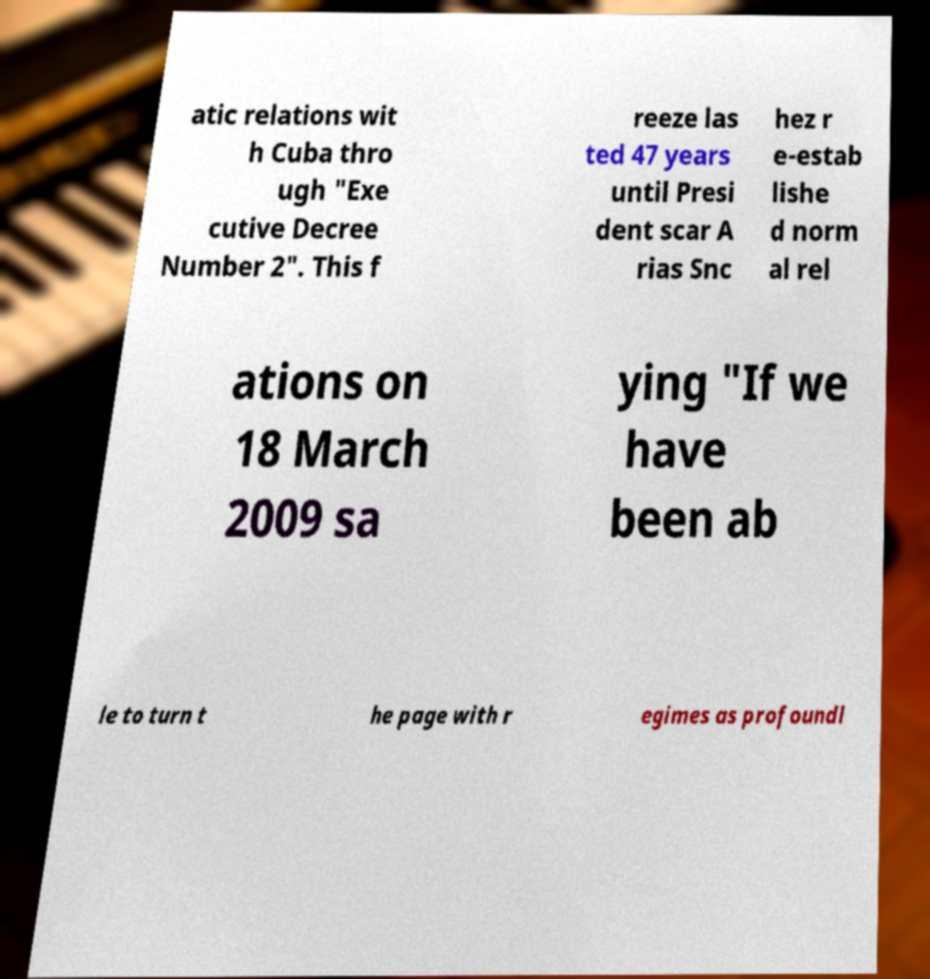Could you assist in decoding the text presented in this image and type it out clearly? atic relations wit h Cuba thro ugh "Exe cutive Decree Number 2". This f reeze las ted 47 years until Presi dent scar A rias Snc hez r e-estab lishe d norm al rel ations on 18 March 2009 sa ying "If we have been ab le to turn t he page with r egimes as profoundl 